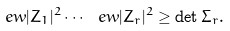Convert formula to latex. <formula><loc_0><loc_0><loc_500><loc_500>\ e w { | Z _ { 1 } | ^ { 2 } } \cdots \ e w { | Z _ { r } | ^ { 2 } } \geq \det \Sigma _ { r } .</formula> 